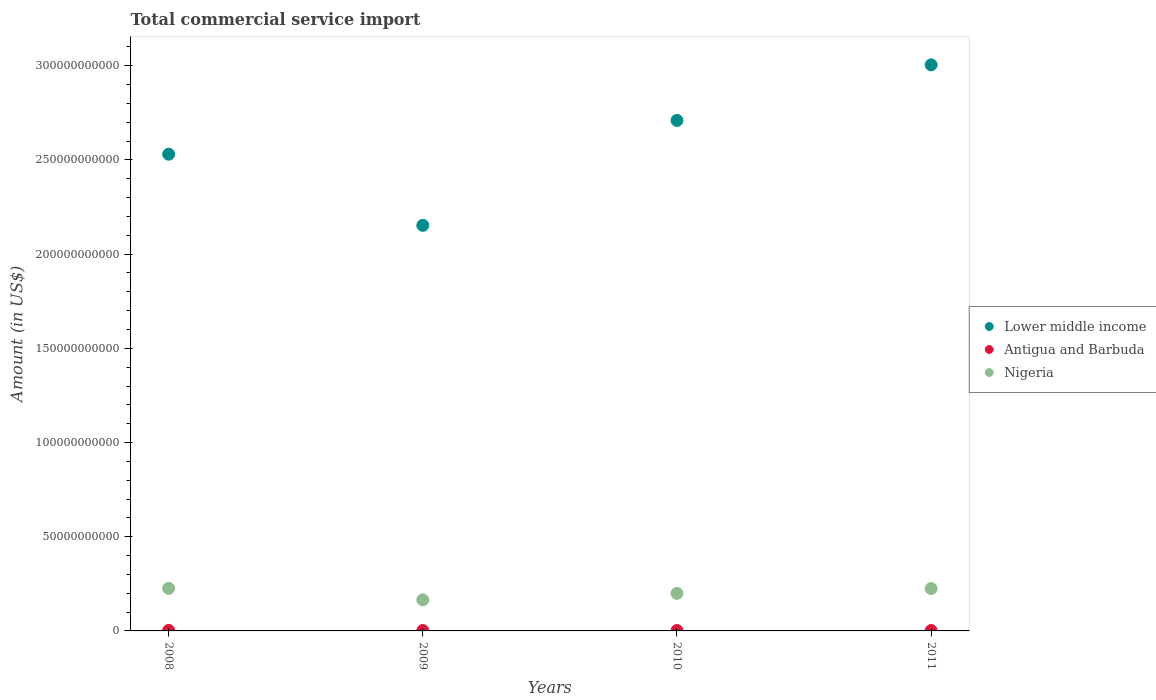Is the number of dotlines equal to the number of legend labels?
Your answer should be very brief. Yes. What is the total commercial service import in Nigeria in 2009?
Your response must be concise. 1.65e+1. Across all years, what is the maximum total commercial service import in Nigeria?
Keep it short and to the point. 2.26e+1. Across all years, what is the minimum total commercial service import in Nigeria?
Give a very brief answer. 1.65e+1. What is the total total commercial service import in Nigeria in the graph?
Ensure brevity in your answer.  8.15e+1. What is the difference between the total commercial service import in Lower middle income in 2009 and that in 2011?
Keep it short and to the point. -8.52e+1. What is the difference between the total commercial service import in Lower middle income in 2011 and the total commercial service import in Antigua and Barbuda in 2008?
Provide a succinct answer. 3.00e+11. What is the average total commercial service import in Nigeria per year?
Your answer should be compact. 2.04e+1. In the year 2011, what is the difference between the total commercial service import in Antigua and Barbuda and total commercial service import in Lower middle income?
Make the answer very short. -3.00e+11. In how many years, is the total commercial service import in Lower middle income greater than 70000000000 US$?
Give a very brief answer. 4. What is the ratio of the total commercial service import in Nigeria in 2010 to that in 2011?
Offer a very short reply. 0.89. Is the total commercial service import in Nigeria in 2008 less than that in 2011?
Give a very brief answer. No. What is the difference between the highest and the second highest total commercial service import in Lower middle income?
Provide a succinct answer. 2.95e+1. What is the difference between the highest and the lowest total commercial service import in Lower middle income?
Offer a very short reply. 8.52e+1. Is it the case that in every year, the sum of the total commercial service import in Nigeria and total commercial service import in Lower middle income  is greater than the total commercial service import in Antigua and Barbuda?
Offer a terse response. Yes. Does the total commercial service import in Antigua and Barbuda monotonically increase over the years?
Offer a terse response. No. What is the difference between two consecutive major ticks on the Y-axis?
Give a very brief answer. 5.00e+1. Are the values on the major ticks of Y-axis written in scientific E-notation?
Provide a short and direct response. No. Does the graph contain any zero values?
Give a very brief answer. No. Does the graph contain grids?
Keep it short and to the point. No. How are the legend labels stacked?
Provide a short and direct response. Vertical. What is the title of the graph?
Keep it short and to the point. Total commercial service import. What is the label or title of the X-axis?
Provide a short and direct response. Years. What is the Amount (in US$) of Lower middle income in 2008?
Offer a terse response. 2.53e+11. What is the Amount (in US$) in Antigua and Barbuda in 2008?
Provide a succinct answer. 2.70e+08. What is the Amount (in US$) in Nigeria in 2008?
Your response must be concise. 2.26e+1. What is the Amount (in US$) of Lower middle income in 2009?
Your response must be concise. 2.15e+11. What is the Amount (in US$) of Antigua and Barbuda in 2009?
Keep it short and to the point. 2.17e+08. What is the Amount (in US$) in Nigeria in 2009?
Your answer should be very brief. 1.65e+1. What is the Amount (in US$) of Lower middle income in 2010?
Offer a terse response. 2.71e+11. What is the Amount (in US$) in Antigua and Barbuda in 2010?
Provide a succinct answer. 2.14e+08. What is the Amount (in US$) in Nigeria in 2010?
Give a very brief answer. 1.99e+1. What is the Amount (in US$) of Lower middle income in 2011?
Offer a very short reply. 3.00e+11. What is the Amount (in US$) of Antigua and Barbuda in 2011?
Ensure brevity in your answer.  2.03e+08. What is the Amount (in US$) in Nigeria in 2011?
Give a very brief answer. 2.25e+1. Across all years, what is the maximum Amount (in US$) in Lower middle income?
Offer a very short reply. 3.00e+11. Across all years, what is the maximum Amount (in US$) in Antigua and Barbuda?
Make the answer very short. 2.70e+08. Across all years, what is the maximum Amount (in US$) in Nigeria?
Ensure brevity in your answer.  2.26e+1. Across all years, what is the minimum Amount (in US$) of Lower middle income?
Keep it short and to the point. 2.15e+11. Across all years, what is the minimum Amount (in US$) of Antigua and Barbuda?
Give a very brief answer. 2.03e+08. Across all years, what is the minimum Amount (in US$) in Nigeria?
Your answer should be compact. 1.65e+1. What is the total Amount (in US$) in Lower middle income in the graph?
Offer a very short reply. 1.04e+12. What is the total Amount (in US$) in Antigua and Barbuda in the graph?
Offer a very short reply. 9.05e+08. What is the total Amount (in US$) of Nigeria in the graph?
Keep it short and to the point. 8.15e+1. What is the difference between the Amount (in US$) in Lower middle income in 2008 and that in 2009?
Offer a terse response. 3.78e+1. What is the difference between the Amount (in US$) in Antigua and Barbuda in 2008 and that in 2009?
Provide a short and direct response. 5.31e+07. What is the difference between the Amount (in US$) in Nigeria in 2008 and that in 2009?
Provide a short and direct response. 6.09e+09. What is the difference between the Amount (in US$) in Lower middle income in 2008 and that in 2010?
Your answer should be compact. -1.79e+1. What is the difference between the Amount (in US$) in Antigua and Barbuda in 2008 and that in 2010?
Your answer should be compact. 5.61e+07. What is the difference between the Amount (in US$) of Nigeria in 2008 and that in 2010?
Your response must be concise. 2.64e+09. What is the difference between the Amount (in US$) of Lower middle income in 2008 and that in 2011?
Provide a short and direct response. -4.74e+1. What is the difference between the Amount (in US$) in Antigua and Barbuda in 2008 and that in 2011?
Provide a succinct answer. 6.72e+07. What is the difference between the Amount (in US$) in Nigeria in 2008 and that in 2011?
Offer a very short reply. 1.04e+08. What is the difference between the Amount (in US$) in Lower middle income in 2009 and that in 2010?
Provide a succinct answer. -5.57e+1. What is the difference between the Amount (in US$) in Antigua and Barbuda in 2009 and that in 2010?
Make the answer very short. 2.99e+06. What is the difference between the Amount (in US$) of Nigeria in 2009 and that in 2010?
Keep it short and to the point. -3.45e+09. What is the difference between the Amount (in US$) of Lower middle income in 2009 and that in 2011?
Your answer should be very brief. -8.52e+1. What is the difference between the Amount (in US$) in Antigua and Barbuda in 2009 and that in 2011?
Keep it short and to the point. 1.41e+07. What is the difference between the Amount (in US$) in Nigeria in 2009 and that in 2011?
Make the answer very short. -5.98e+09. What is the difference between the Amount (in US$) in Lower middle income in 2010 and that in 2011?
Provide a succinct answer. -2.95e+1. What is the difference between the Amount (in US$) in Antigua and Barbuda in 2010 and that in 2011?
Provide a succinct answer. 1.11e+07. What is the difference between the Amount (in US$) of Nigeria in 2010 and that in 2011?
Give a very brief answer. -2.53e+09. What is the difference between the Amount (in US$) in Lower middle income in 2008 and the Amount (in US$) in Antigua and Barbuda in 2009?
Keep it short and to the point. 2.53e+11. What is the difference between the Amount (in US$) in Lower middle income in 2008 and the Amount (in US$) in Nigeria in 2009?
Offer a terse response. 2.37e+11. What is the difference between the Amount (in US$) of Antigua and Barbuda in 2008 and the Amount (in US$) of Nigeria in 2009?
Ensure brevity in your answer.  -1.62e+1. What is the difference between the Amount (in US$) of Lower middle income in 2008 and the Amount (in US$) of Antigua and Barbuda in 2010?
Make the answer very short. 2.53e+11. What is the difference between the Amount (in US$) in Lower middle income in 2008 and the Amount (in US$) in Nigeria in 2010?
Give a very brief answer. 2.33e+11. What is the difference between the Amount (in US$) in Antigua and Barbuda in 2008 and the Amount (in US$) in Nigeria in 2010?
Make the answer very short. -1.97e+1. What is the difference between the Amount (in US$) of Lower middle income in 2008 and the Amount (in US$) of Antigua and Barbuda in 2011?
Your response must be concise. 2.53e+11. What is the difference between the Amount (in US$) in Lower middle income in 2008 and the Amount (in US$) in Nigeria in 2011?
Keep it short and to the point. 2.31e+11. What is the difference between the Amount (in US$) in Antigua and Barbuda in 2008 and the Amount (in US$) in Nigeria in 2011?
Make the answer very short. -2.22e+1. What is the difference between the Amount (in US$) of Lower middle income in 2009 and the Amount (in US$) of Antigua and Barbuda in 2010?
Offer a terse response. 2.15e+11. What is the difference between the Amount (in US$) in Lower middle income in 2009 and the Amount (in US$) in Nigeria in 2010?
Your response must be concise. 1.95e+11. What is the difference between the Amount (in US$) in Antigua and Barbuda in 2009 and the Amount (in US$) in Nigeria in 2010?
Make the answer very short. -1.97e+1. What is the difference between the Amount (in US$) in Lower middle income in 2009 and the Amount (in US$) in Antigua and Barbuda in 2011?
Ensure brevity in your answer.  2.15e+11. What is the difference between the Amount (in US$) in Lower middle income in 2009 and the Amount (in US$) in Nigeria in 2011?
Keep it short and to the point. 1.93e+11. What is the difference between the Amount (in US$) in Antigua and Barbuda in 2009 and the Amount (in US$) in Nigeria in 2011?
Ensure brevity in your answer.  -2.23e+1. What is the difference between the Amount (in US$) in Lower middle income in 2010 and the Amount (in US$) in Antigua and Barbuda in 2011?
Offer a terse response. 2.71e+11. What is the difference between the Amount (in US$) of Lower middle income in 2010 and the Amount (in US$) of Nigeria in 2011?
Make the answer very short. 2.49e+11. What is the difference between the Amount (in US$) of Antigua and Barbuda in 2010 and the Amount (in US$) of Nigeria in 2011?
Your response must be concise. -2.23e+1. What is the average Amount (in US$) in Lower middle income per year?
Provide a succinct answer. 2.60e+11. What is the average Amount (in US$) of Antigua and Barbuda per year?
Give a very brief answer. 2.26e+08. What is the average Amount (in US$) in Nigeria per year?
Make the answer very short. 2.04e+1. In the year 2008, what is the difference between the Amount (in US$) in Lower middle income and Amount (in US$) in Antigua and Barbuda?
Your answer should be compact. 2.53e+11. In the year 2008, what is the difference between the Amount (in US$) in Lower middle income and Amount (in US$) in Nigeria?
Provide a short and direct response. 2.30e+11. In the year 2008, what is the difference between the Amount (in US$) in Antigua and Barbuda and Amount (in US$) in Nigeria?
Your answer should be compact. -2.23e+1. In the year 2009, what is the difference between the Amount (in US$) of Lower middle income and Amount (in US$) of Antigua and Barbuda?
Ensure brevity in your answer.  2.15e+11. In the year 2009, what is the difference between the Amount (in US$) of Lower middle income and Amount (in US$) of Nigeria?
Provide a succinct answer. 1.99e+11. In the year 2009, what is the difference between the Amount (in US$) in Antigua and Barbuda and Amount (in US$) in Nigeria?
Ensure brevity in your answer.  -1.63e+1. In the year 2010, what is the difference between the Amount (in US$) of Lower middle income and Amount (in US$) of Antigua and Barbuda?
Make the answer very short. 2.71e+11. In the year 2010, what is the difference between the Amount (in US$) of Lower middle income and Amount (in US$) of Nigeria?
Ensure brevity in your answer.  2.51e+11. In the year 2010, what is the difference between the Amount (in US$) in Antigua and Barbuda and Amount (in US$) in Nigeria?
Offer a very short reply. -1.97e+1. In the year 2011, what is the difference between the Amount (in US$) of Lower middle income and Amount (in US$) of Antigua and Barbuda?
Your response must be concise. 3.00e+11. In the year 2011, what is the difference between the Amount (in US$) in Lower middle income and Amount (in US$) in Nigeria?
Your response must be concise. 2.78e+11. In the year 2011, what is the difference between the Amount (in US$) in Antigua and Barbuda and Amount (in US$) in Nigeria?
Give a very brief answer. -2.23e+1. What is the ratio of the Amount (in US$) in Lower middle income in 2008 to that in 2009?
Provide a short and direct response. 1.18. What is the ratio of the Amount (in US$) in Antigua and Barbuda in 2008 to that in 2009?
Your answer should be very brief. 1.24. What is the ratio of the Amount (in US$) in Nigeria in 2008 to that in 2009?
Ensure brevity in your answer.  1.37. What is the ratio of the Amount (in US$) in Lower middle income in 2008 to that in 2010?
Provide a succinct answer. 0.93. What is the ratio of the Amount (in US$) in Antigua and Barbuda in 2008 to that in 2010?
Ensure brevity in your answer.  1.26. What is the ratio of the Amount (in US$) in Nigeria in 2008 to that in 2010?
Ensure brevity in your answer.  1.13. What is the ratio of the Amount (in US$) of Lower middle income in 2008 to that in 2011?
Give a very brief answer. 0.84. What is the ratio of the Amount (in US$) of Antigua and Barbuda in 2008 to that in 2011?
Provide a succinct answer. 1.33. What is the ratio of the Amount (in US$) of Lower middle income in 2009 to that in 2010?
Keep it short and to the point. 0.79. What is the ratio of the Amount (in US$) of Antigua and Barbuda in 2009 to that in 2010?
Provide a short and direct response. 1.01. What is the ratio of the Amount (in US$) of Nigeria in 2009 to that in 2010?
Your answer should be compact. 0.83. What is the ratio of the Amount (in US$) in Lower middle income in 2009 to that in 2011?
Make the answer very short. 0.72. What is the ratio of the Amount (in US$) of Antigua and Barbuda in 2009 to that in 2011?
Provide a succinct answer. 1.07. What is the ratio of the Amount (in US$) of Nigeria in 2009 to that in 2011?
Keep it short and to the point. 0.73. What is the ratio of the Amount (in US$) of Lower middle income in 2010 to that in 2011?
Your answer should be compact. 0.9. What is the ratio of the Amount (in US$) of Antigua and Barbuda in 2010 to that in 2011?
Ensure brevity in your answer.  1.05. What is the ratio of the Amount (in US$) of Nigeria in 2010 to that in 2011?
Your answer should be very brief. 0.89. What is the difference between the highest and the second highest Amount (in US$) in Lower middle income?
Your answer should be compact. 2.95e+1. What is the difference between the highest and the second highest Amount (in US$) in Antigua and Barbuda?
Offer a terse response. 5.31e+07. What is the difference between the highest and the second highest Amount (in US$) in Nigeria?
Offer a very short reply. 1.04e+08. What is the difference between the highest and the lowest Amount (in US$) in Lower middle income?
Offer a very short reply. 8.52e+1. What is the difference between the highest and the lowest Amount (in US$) in Antigua and Barbuda?
Keep it short and to the point. 6.72e+07. What is the difference between the highest and the lowest Amount (in US$) of Nigeria?
Ensure brevity in your answer.  6.09e+09. 